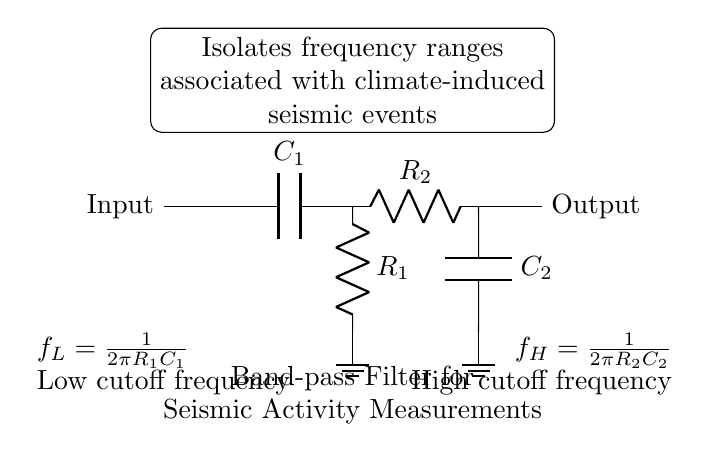What is the purpose of this circuit? The purpose of the circuit is to isolate specific frequency ranges associated with climate-induced seismic events. This can be inferred from the annotation which specifically states this function.
Answer: Isolate frequency ranges associated with climate-induced seismic events What components are used in the high-pass filter section? The high-pass filter section consists of a capacitor labeled C1 and a resistor labeled R1. The diagram clearly labels these components in the respective locations.
Answer: Capacitor C1 and Resistor R1 What is the low cutoff frequency formula? The low cutoff frequency formula is given as f_L = 1 / (2π R1 C1), which is noted below the high-pass filter section. This formula shows the relationship between R1, C1, and the cutoff frequency.
Answer: f_L = 1 / (2π R1 C1) What is found at the output of this circuit? The output of the circuit is indicated simply as "Output," showing that the processed signal will be output from the right side. There's no specific value or parameter provided, just the indication of an output connection.
Answer: Output How are the low-pass and high-pass filters connected? The low-pass filter is connected in series after the high-pass filter, meaning that the signal first passes through the high-pass section before going to the low-pass section. This is reflected in the progression of lines connecting the components in a linear path.
Answer: In series What do the components R2 and C2 represent? R2 represents the resistor in the low-pass filter section, while C2 represents the capacitor. The labels next to these components confirm their identities and roles in setting the high cutoff frequency of the circuit.
Answer: Resistor R2 and Capacitor C2 